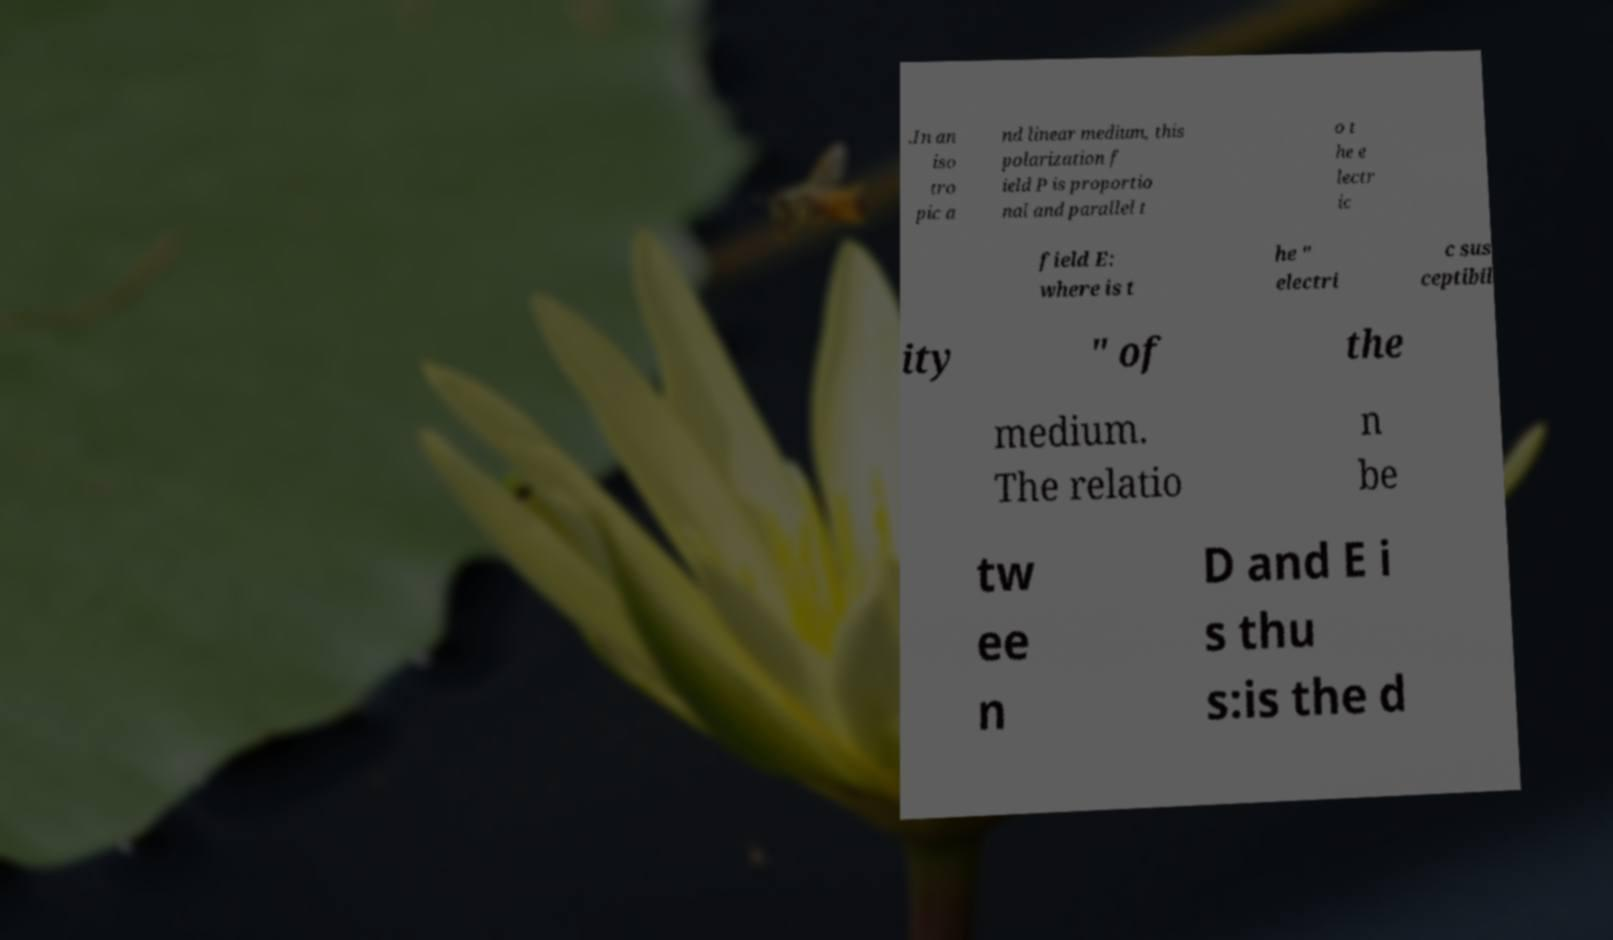Please read and relay the text visible in this image. What does it say? .In an iso tro pic a nd linear medium, this polarization f ield P is proportio nal and parallel t o t he e lectr ic field E: where is t he " electri c sus ceptibil ity " of the medium. The relatio n be tw ee n D and E i s thu s:is the d 